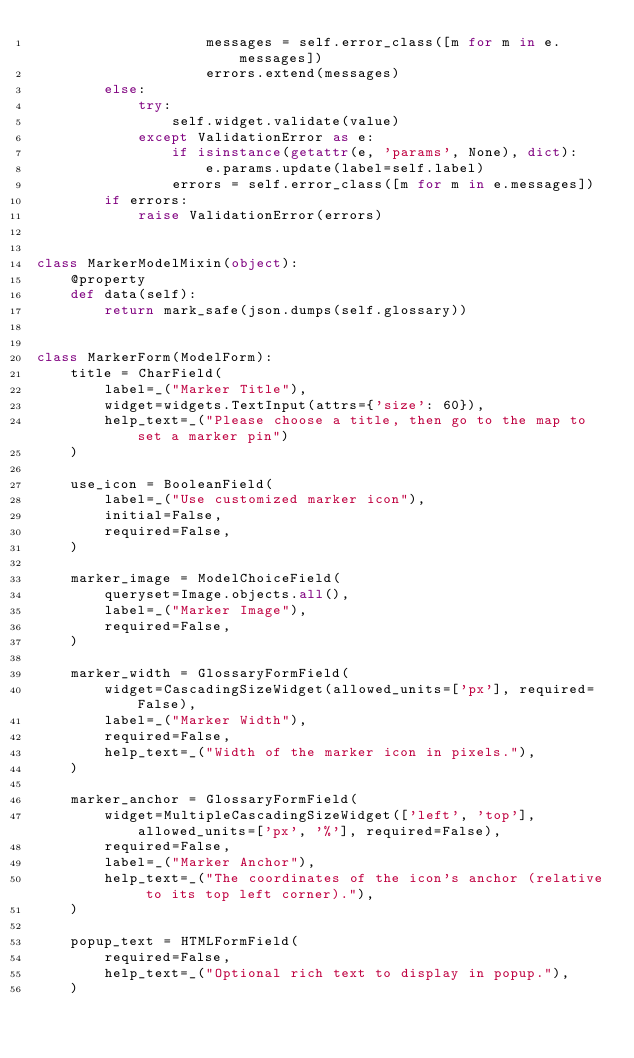<code> <loc_0><loc_0><loc_500><loc_500><_Python_>                    messages = self.error_class([m for m in e.messages])
                    errors.extend(messages)
        else:
            try:
                self.widget.validate(value)
            except ValidationError as e:
                if isinstance(getattr(e, 'params', None), dict):
                    e.params.update(label=self.label)
                errors = self.error_class([m for m in e.messages])
        if errors:
            raise ValidationError(errors)


class MarkerModelMixin(object):
    @property
    def data(self):
        return mark_safe(json.dumps(self.glossary))


class MarkerForm(ModelForm):
    title = CharField(
        label=_("Marker Title"),
        widget=widgets.TextInput(attrs={'size': 60}),
        help_text=_("Please choose a title, then go to the map to set a marker pin")
    )

    use_icon = BooleanField(
        label=_("Use customized marker icon"),
        initial=False,
        required=False,
    )

    marker_image = ModelChoiceField(
        queryset=Image.objects.all(),
        label=_("Marker Image"),
        required=False,
    )

    marker_width = GlossaryFormField(
        widget=CascadingSizeWidget(allowed_units=['px'], required=False),
        label=_("Marker Width"),
        required=False,
        help_text=_("Width of the marker icon in pixels."),
    )

    marker_anchor = GlossaryFormField(
        widget=MultipleCascadingSizeWidget(['left', 'top'], allowed_units=['px', '%'], required=False),
        required=False,
        label=_("Marker Anchor"),
        help_text=_("The coordinates of the icon's anchor (relative to its top left corner)."),
    )

    popup_text = HTMLFormField(
        required=False,
        help_text=_("Optional rich text to display in popup."),
    )
</code> 